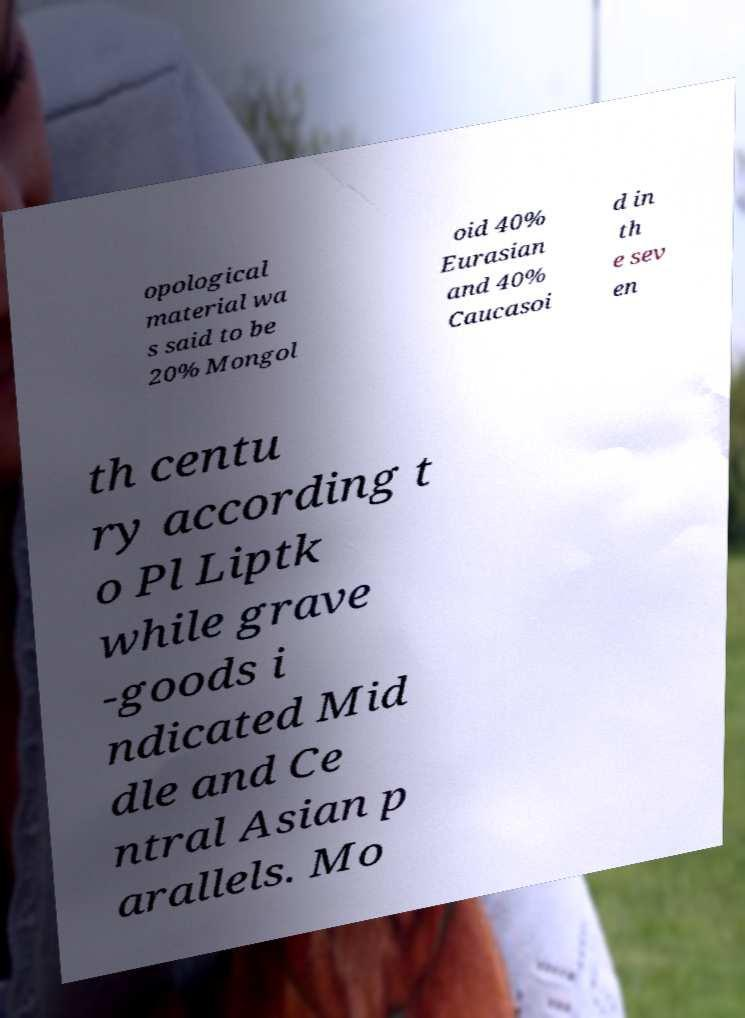What messages or text are displayed in this image? I need them in a readable, typed format. opological material wa s said to be 20% Mongol oid 40% Eurasian and 40% Caucasoi d in th e sev en th centu ry according t o Pl Liptk while grave -goods i ndicated Mid dle and Ce ntral Asian p arallels. Mo 